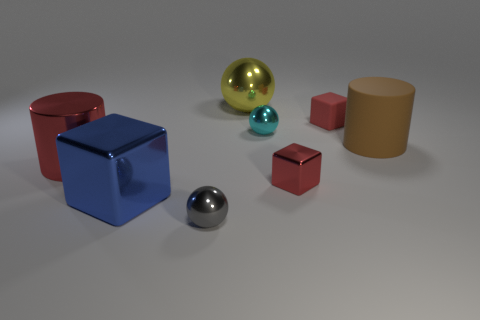Add 1 cyan metallic spheres. How many objects exist? 9 Subtract all balls. How many objects are left? 5 Add 5 small cyan balls. How many small cyan balls exist? 6 Subtract 1 cyan spheres. How many objects are left? 7 Subtract all blue shiny cubes. Subtract all tiny metallic spheres. How many objects are left? 5 Add 7 yellow shiny spheres. How many yellow shiny spheres are left? 8 